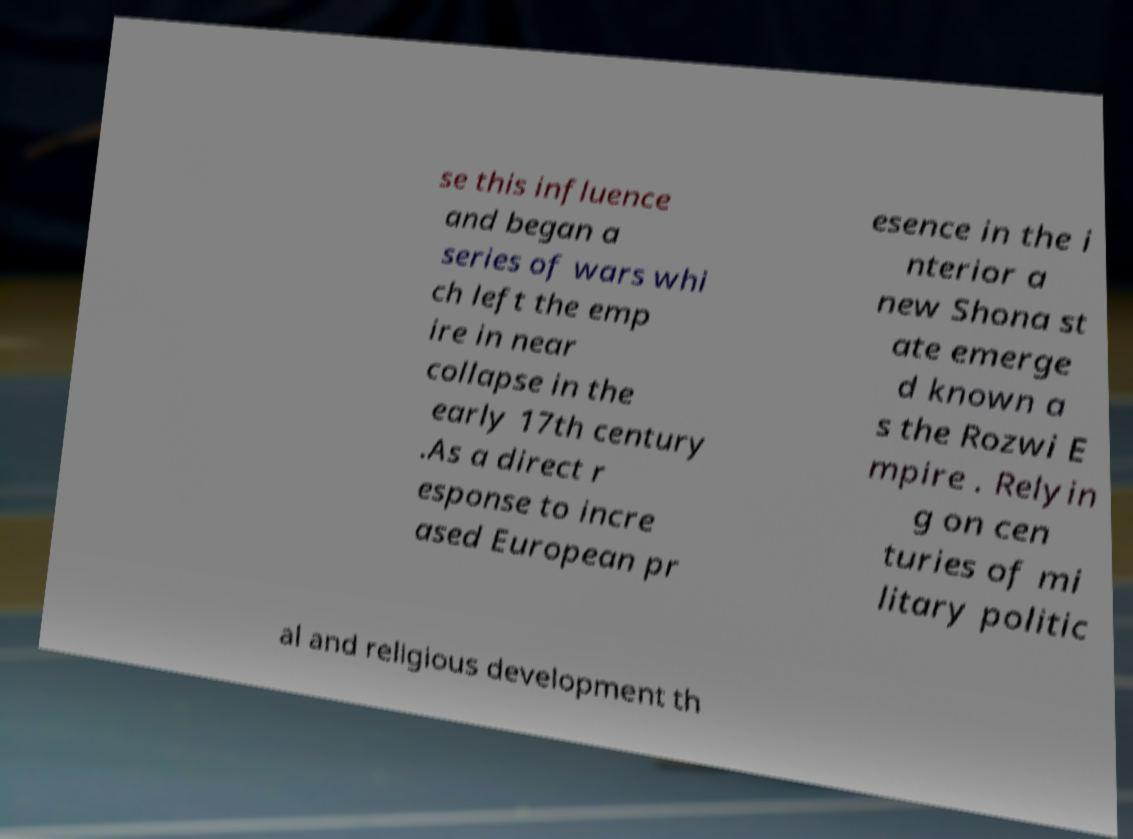Could you assist in decoding the text presented in this image and type it out clearly? se this influence and began a series of wars whi ch left the emp ire in near collapse in the early 17th century .As a direct r esponse to incre ased European pr esence in the i nterior a new Shona st ate emerge d known a s the Rozwi E mpire . Relyin g on cen turies of mi litary politic al and religious development th 